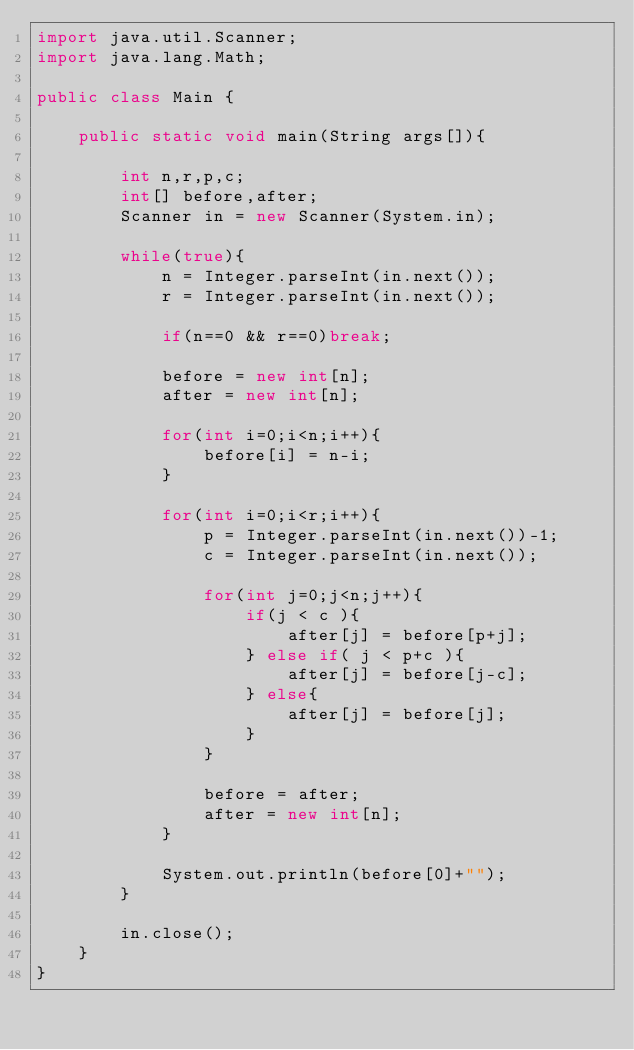Convert code to text. <code><loc_0><loc_0><loc_500><loc_500><_Java_>import java.util.Scanner;
import java.lang.Math;

public class Main {

	public static void main(String args[]){
		
		int n,r,p,c;
		int[] before,after;
		Scanner in = new Scanner(System.in);
		
		while(true){
			n = Integer.parseInt(in.next());
			r = Integer.parseInt(in.next());
			
			if(n==0 && r==0)break;
			
			before = new int[n];
			after = new int[n];
			
			for(int i=0;i<n;i++){
				before[i] = n-i;
			}
			
			for(int i=0;i<r;i++){
				p = Integer.parseInt(in.next())-1;
				c = Integer.parseInt(in.next());
				
				for(int j=0;j<n;j++){
					if(j < c ){
						after[j] = before[p+j];
					} else if( j < p+c ){
						after[j] = before[j-c];
					} else{
						after[j] = before[j];
					}
				}
				
				before = after;
				after = new int[n];
			}
			
			System.out.println(before[0]+"");
		}
		
		in.close();
	}
}</code> 